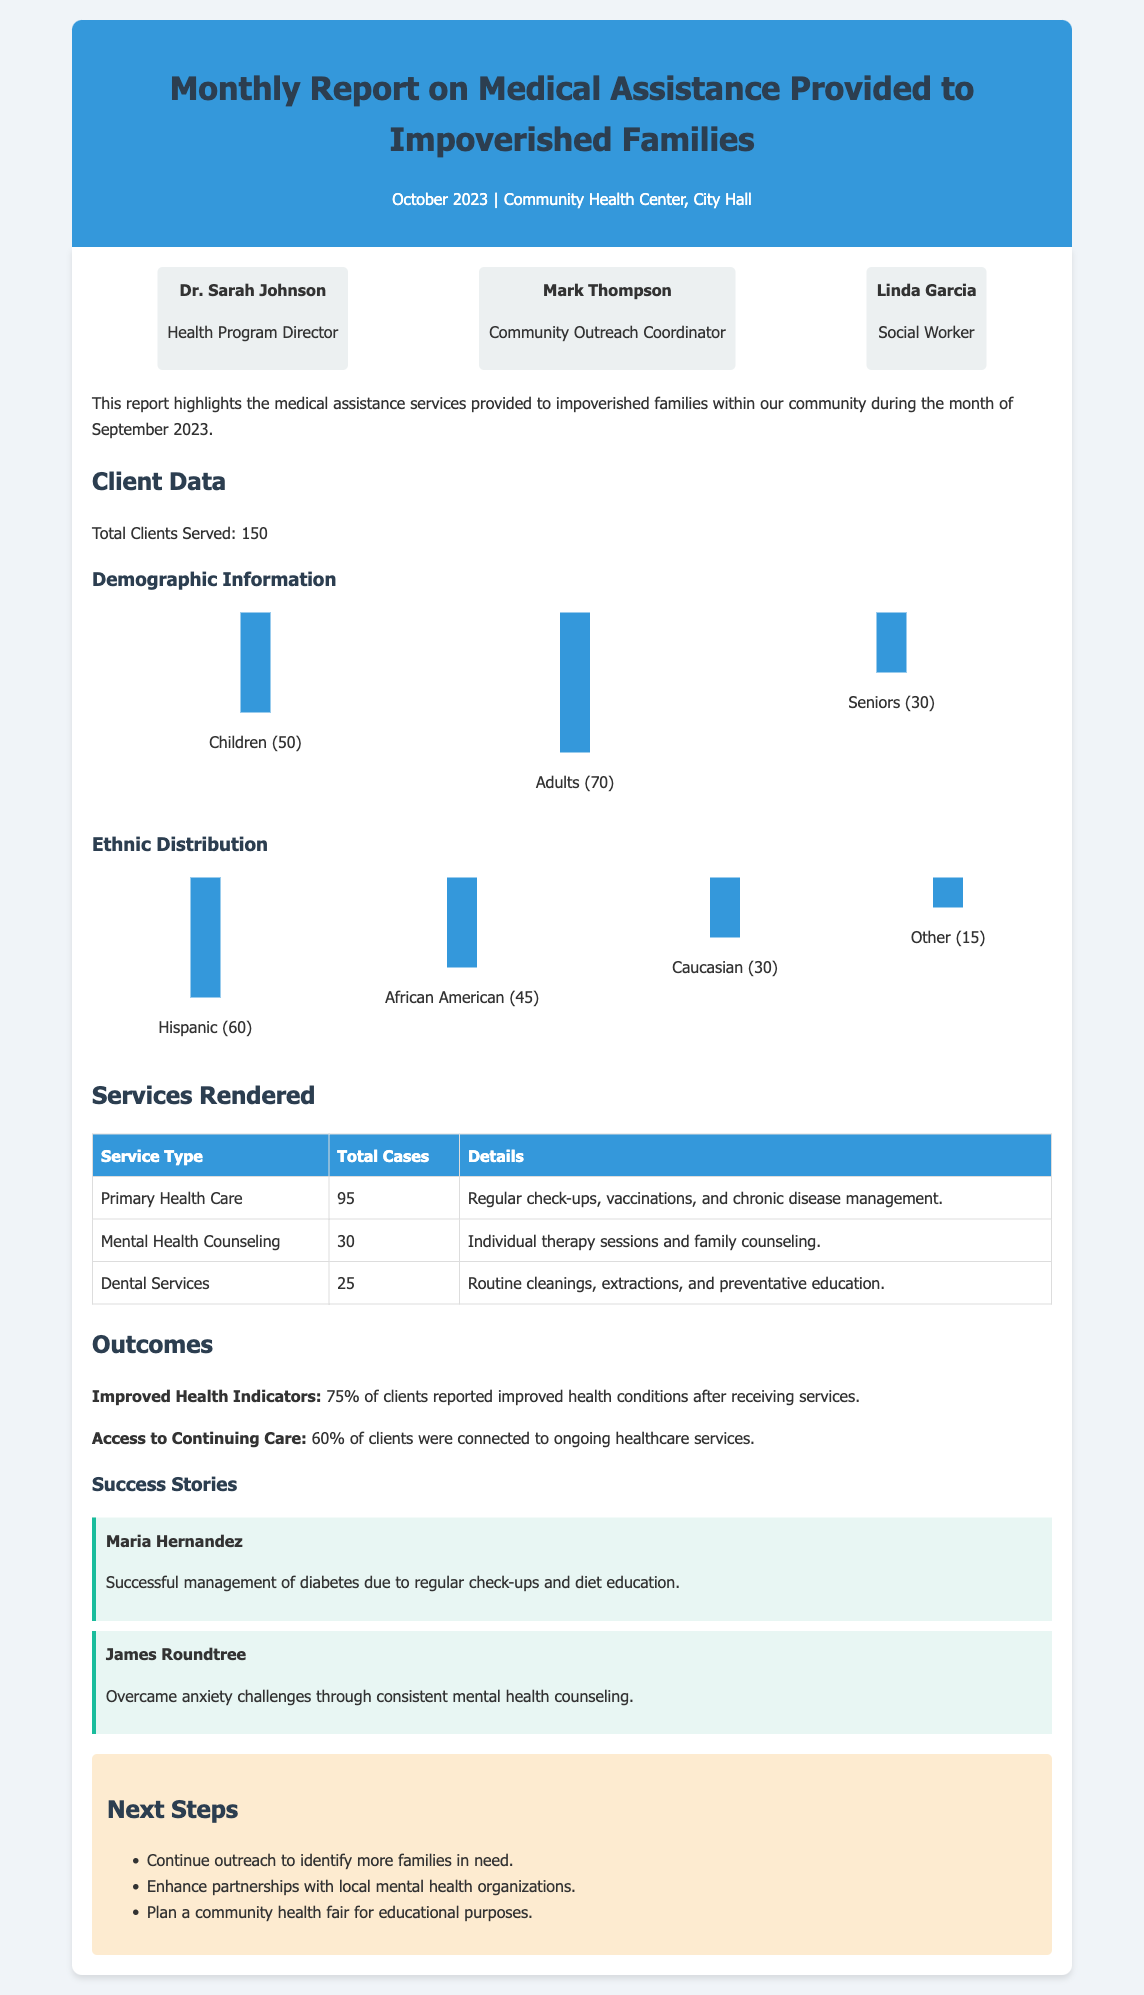What is the total number of clients served? The total number of clients served is specifically mentioned in the data section of the report.
Answer: 150 How many adults received services? The demographic breakdown indicates that the number of adults served is clearly stated.
Answer: 70 What percentage of clients reported improved health conditions? The outcomes section provides a specific percentage regarding the improvement in health indicators among clients.
Answer: 75% What service type had the highest number of cases? The services rendered section lists the total cases for each service, allowing us to identify the one with the highest number.
Answer: Primary Health Care How many clients were connected to ongoing healthcare services? The outcomes section specifies the percentage of clients who were linked to continuing care, allowing us to retrieve that information easily.
Answer: 60% Who is the Health Program Director? The participants section names the individuals involved in the report along with their titles.
Answer: Dr. Sarah Johnson What is one success story mentioned in the report? The section on success stories provides individual examples of positive outcomes from the services provided.
Answer: Maria Hernandez Which month does this report cover? The header of the document provides the specific month being reported on, indicating the timeframe of the report.
Answer: October 2023 What future step involves community outreach? The next steps section outlines actions planned for future improvements and outreach efforts.
Answer: Continue outreach to identify more families in need 